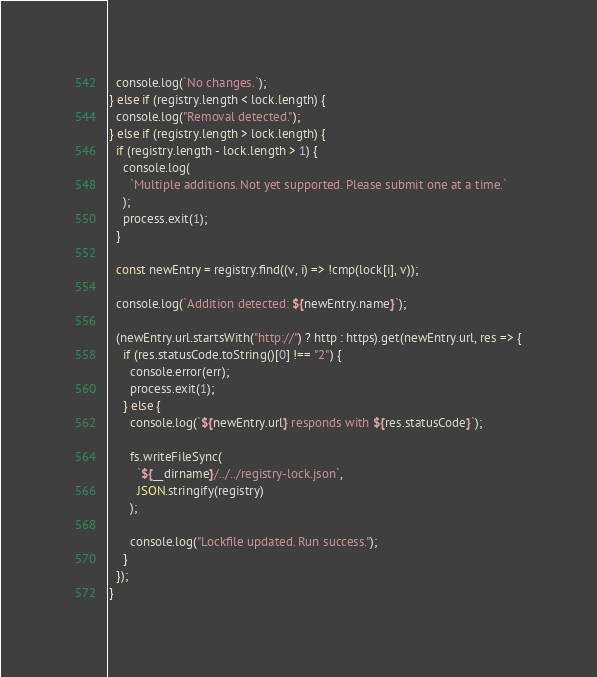<code> <loc_0><loc_0><loc_500><loc_500><_JavaScript_>  console.log(`No changes.`);
} else if (registry.length < lock.length) {
  console.log("Removal detected.");
} else if (registry.length > lock.length) {
  if (registry.length - lock.length > 1) {
    console.log(
      `Multiple additions. Not yet supported. Please submit one at a time.`
    );
    process.exit(1);
  }

  const newEntry = registry.find((v, i) => !cmp(lock[i], v));

  console.log(`Addition detected: ${newEntry.name}`);

  (newEntry.url.startsWith("http://") ? http : https).get(newEntry.url, res => {
    if (res.statusCode.toString()[0] !== "2") {
      console.error(err);
      process.exit(1);
    } else {
      console.log(`${newEntry.url} responds with ${res.statusCode}`);

      fs.writeFileSync(
        `${__dirname}/../../registry-lock.json`,
        JSON.stringify(registry)
      );

      console.log("Lockfile updated. Run success.");
    }
  });
}
</code> 